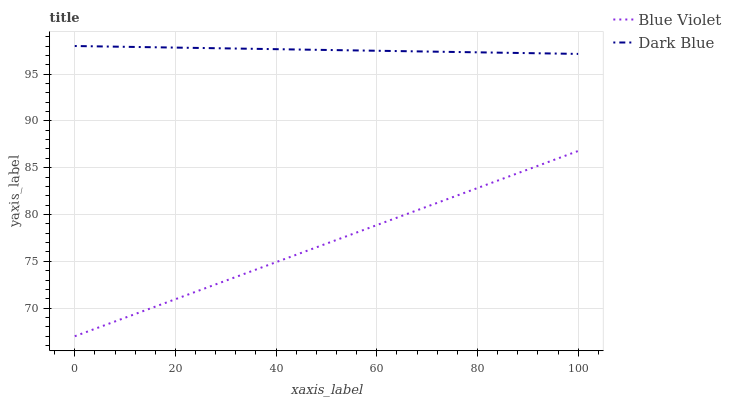Does Blue Violet have the minimum area under the curve?
Answer yes or no. Yes. Does Dark Blue have the maximum area under the curve?
Answer yes or no. Yes. Does Blue Violet have the maximum area under the curve?
Answer yes or no. No. Is Dark Blue the smoothest?
Answer yes or no. Yes. Is Blue Violet the roughest?
Answer yes or no. Yes. Is Blue Violet the smoothest?
Answer yes or no. No. Does Blue Violet have the lowest value?
Answer yes or no. Yes. Does Dark Blue have the highest value?
Answer yes or no. Yes. Does Blue Violet have the highest value?
Answer yes or no. No. Is Blue Violet less than Dark Blue?
Answer yes or no. Yes. Is Dark Blue greater than Blue Violet?
Answer yes or no. Yes. Does Blue Violet intersect Dark Blue?
Answer yes or no. No. 